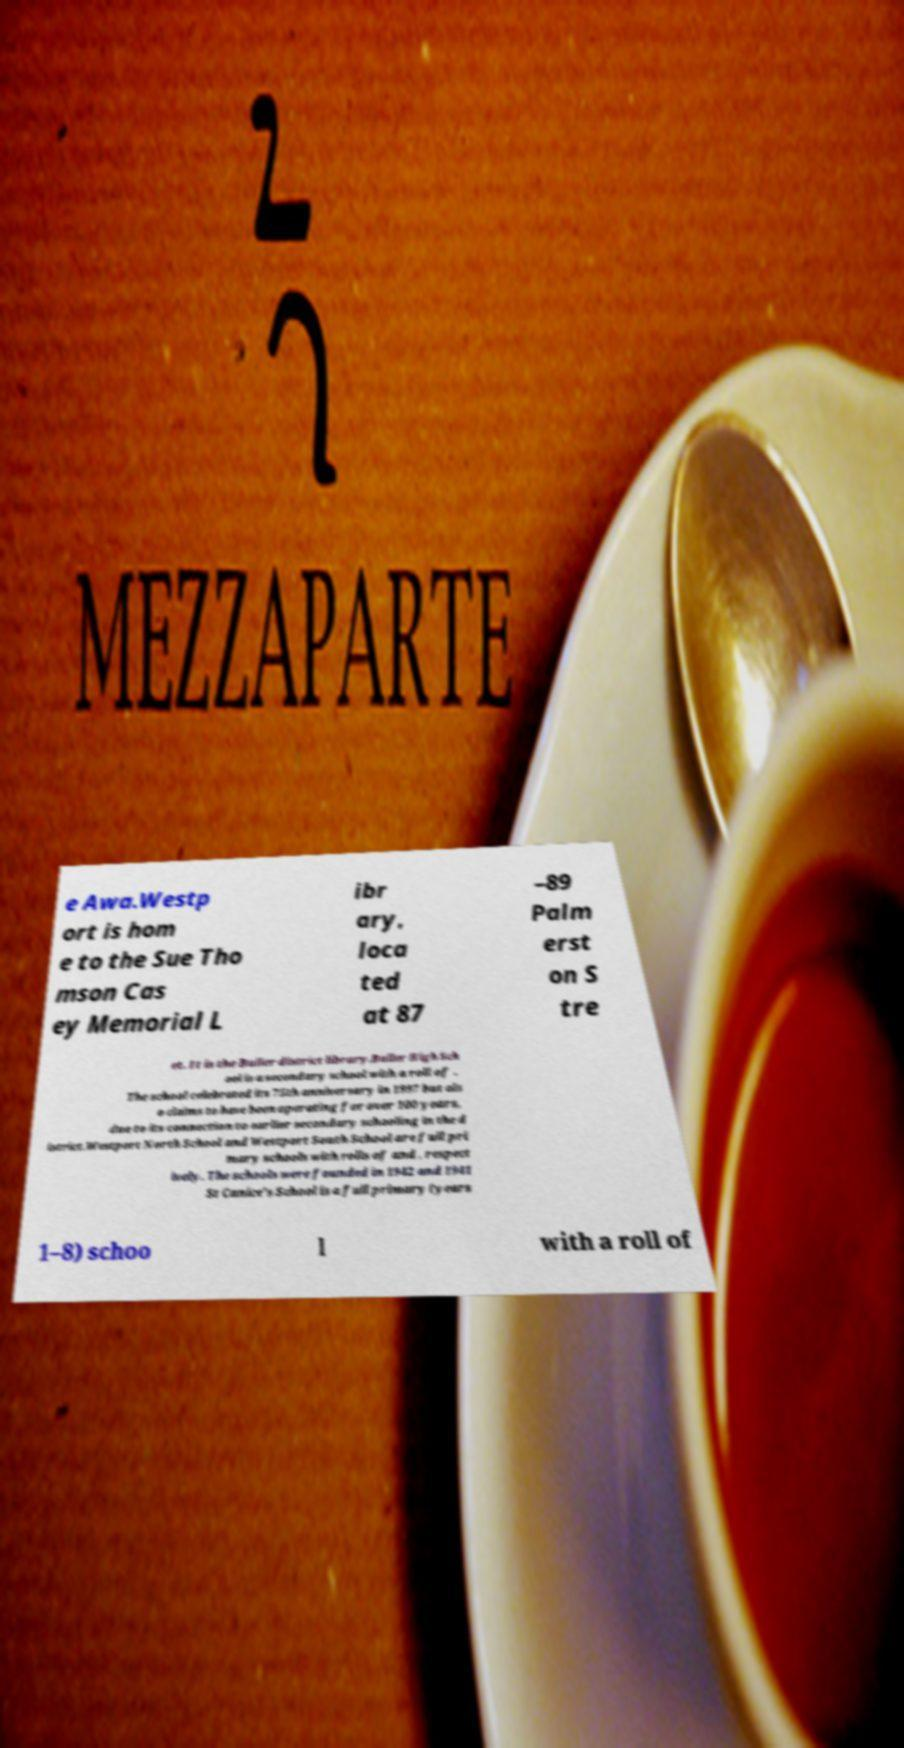Could you extract and type out the text from this image? e Awa.Westp ort is hom e to the Sue Tho mson Cas ey Memorial L ibr ary, loca ted at 87 –89 Palm erst on S tre et. It is the Buller district library.Buller High Sch ool is a secondary school with a roll of . The school celebrated its 75th anniversary in 1997 but als o claims to have been operating for over 100 years, due to its connection to earlier secondary schooling in the d istrict.Westport North School and Westport South School are full pri mary schools with rolls of and , respect ively. The schools were founded in 1942 and 1941 St Canice's School is a full primary (years 1–8) schoo l with a roll of 